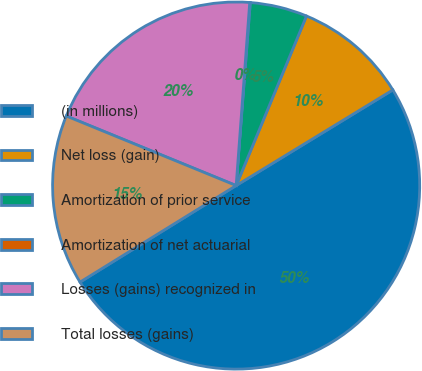Convert chart. <chart><loc_0><loc_0><loc_500><loc_500><pie_chart><fcel>(in millions)<fcel>Net loss (gain)<fcel>Amortization of prior service<fcel>Amortization of net actuarial<fcel>Losses (gains) recognized in<fcel>Total losses (gains)<nl><fcel>49.9%<fcel>10.02%<fcel>5.03%<fcel>0.05%<fcel>19.99%<fcel>15.0%<nl></chart> 